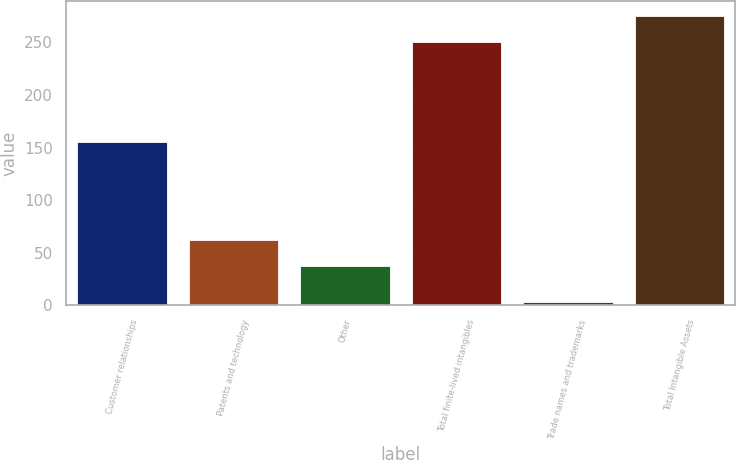Convert chart. <chart><loc_0><loc_0><loc_500><loc_500><bar_chart><fcel>Customer relationships<fcel>Patents and technology<fcel>Other<fcel>Total finite-lived intangibles<fcel>Trade names and trademarks<fcel>Total Intangible Assets<nl><fcel>155.2<fcel>62.34<fcel>37.3<fcel>250.4<fcel>3.5<fcel>275.44<nl></chart> 